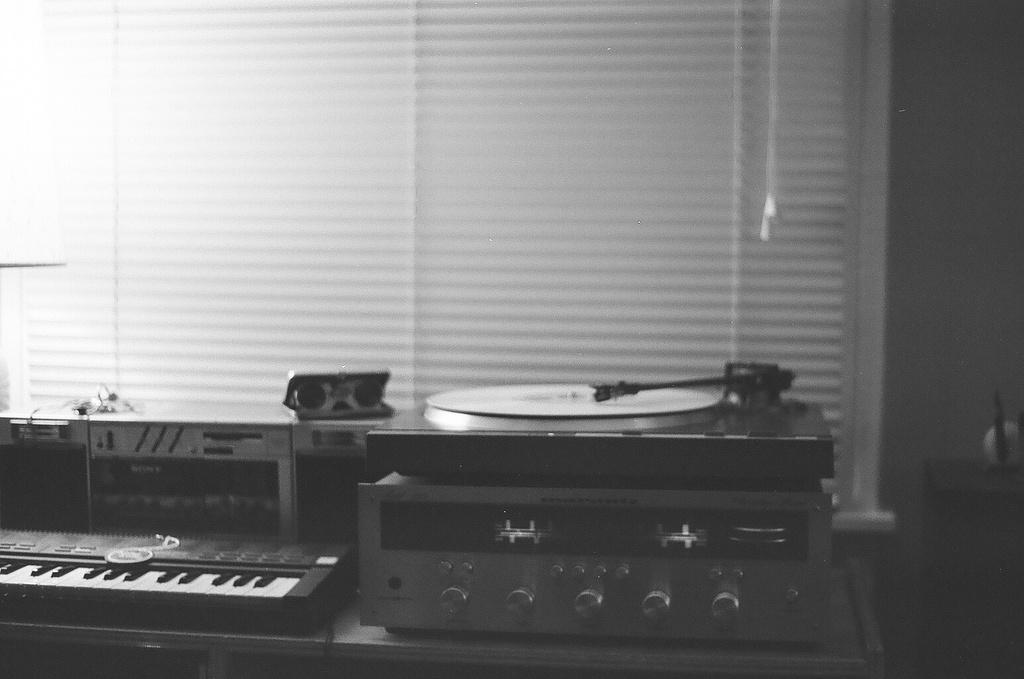In one or two sentences, can you explain what this image depicts? In this picture there is a piano, there is also a musical equipment, there is a CD player, in the backdrop there is a wall and a window. 